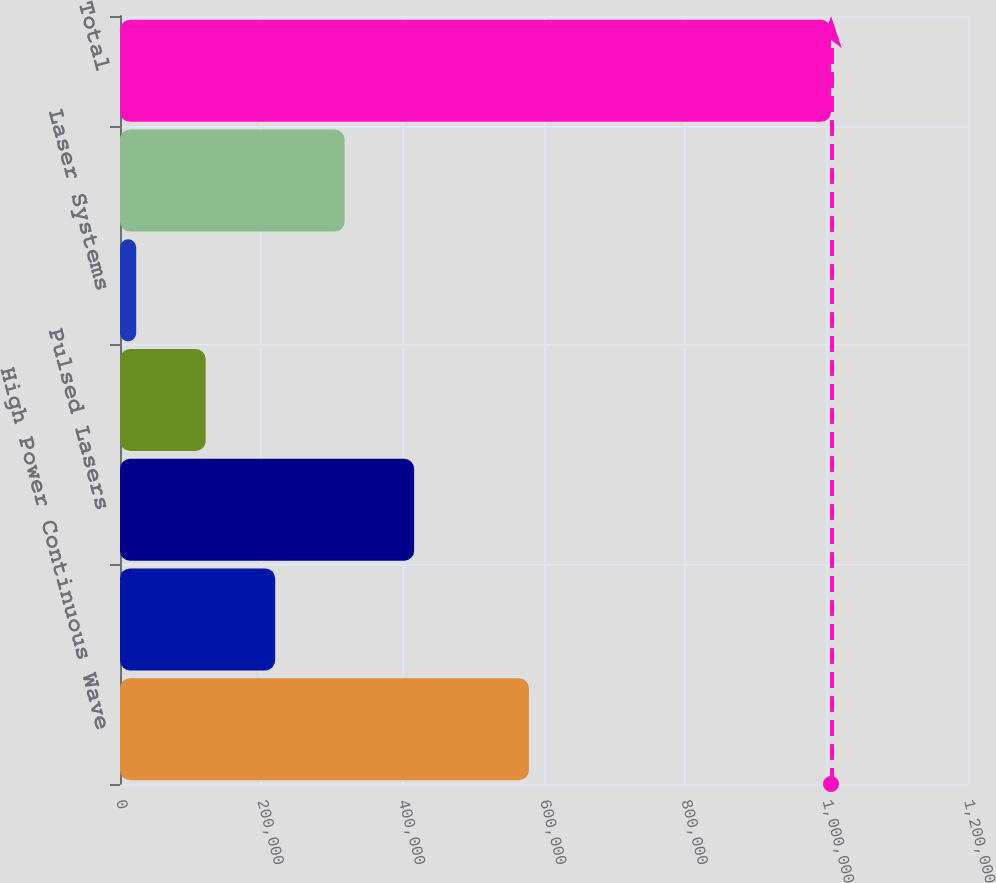<chart> <loc_0><loc_0><loc_500><loc_500><bar_chart><fcel>High Power Continuous Wave<fcel>Medium and Low Power CW Lasers<fcel>Pulsed Lasers<fcel>Quasi-Continuous Wave (QCW)<fcel>Laser Systems<fcel>Other Revenue including<fcel>Total<nl><fcel>578668<fcel>219589<fcel>416235<fcel>121266<fcel>22943<fcel>317912<fcel>1.00617e+06<nl></chart> 